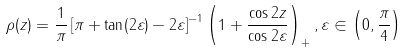<formula> <loc_0><loc_0><loc_500><loc_500>\rho ( z ) = \frac { 1 } { \pi } \left [ \pi + \tan ( 2 \varepsilon ) - 2 \varepsilon \right ] ^ { - 1 } \left ( 1 + \frac { \cos 2 z } { \cos 2 \varepsilon } \right ) _ { + } , \varepsilon \in \left ( 0 , \frac { \pi } { 4 } \right )</formula> 